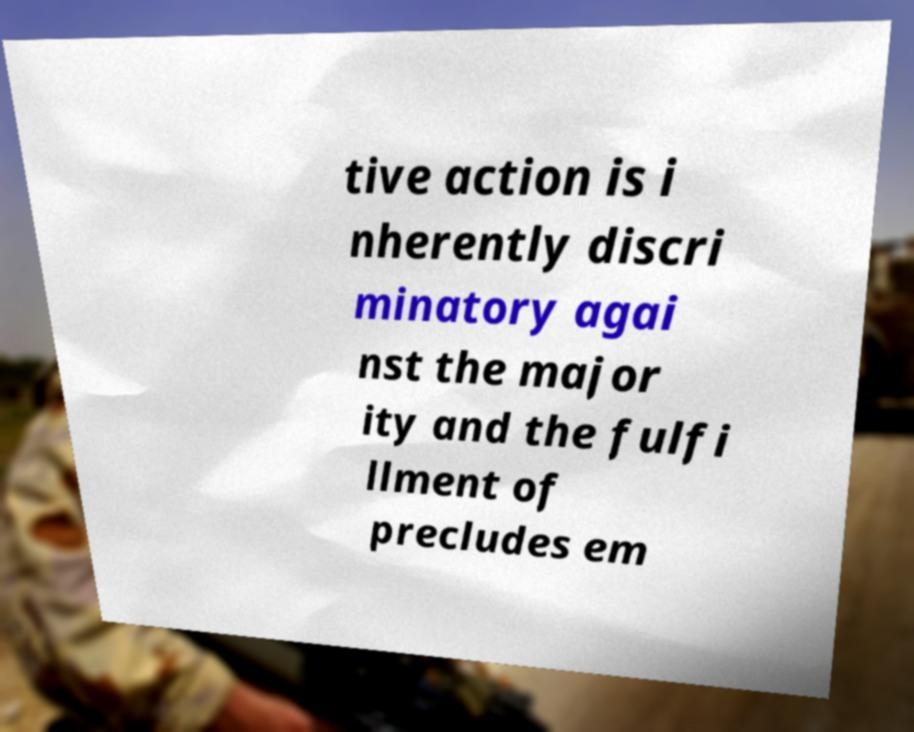Can you accurately transcribe the text from the provided image for me? tive action is i nherently discri minatory agai nst the major ity and the fulfi llment of precludes em 